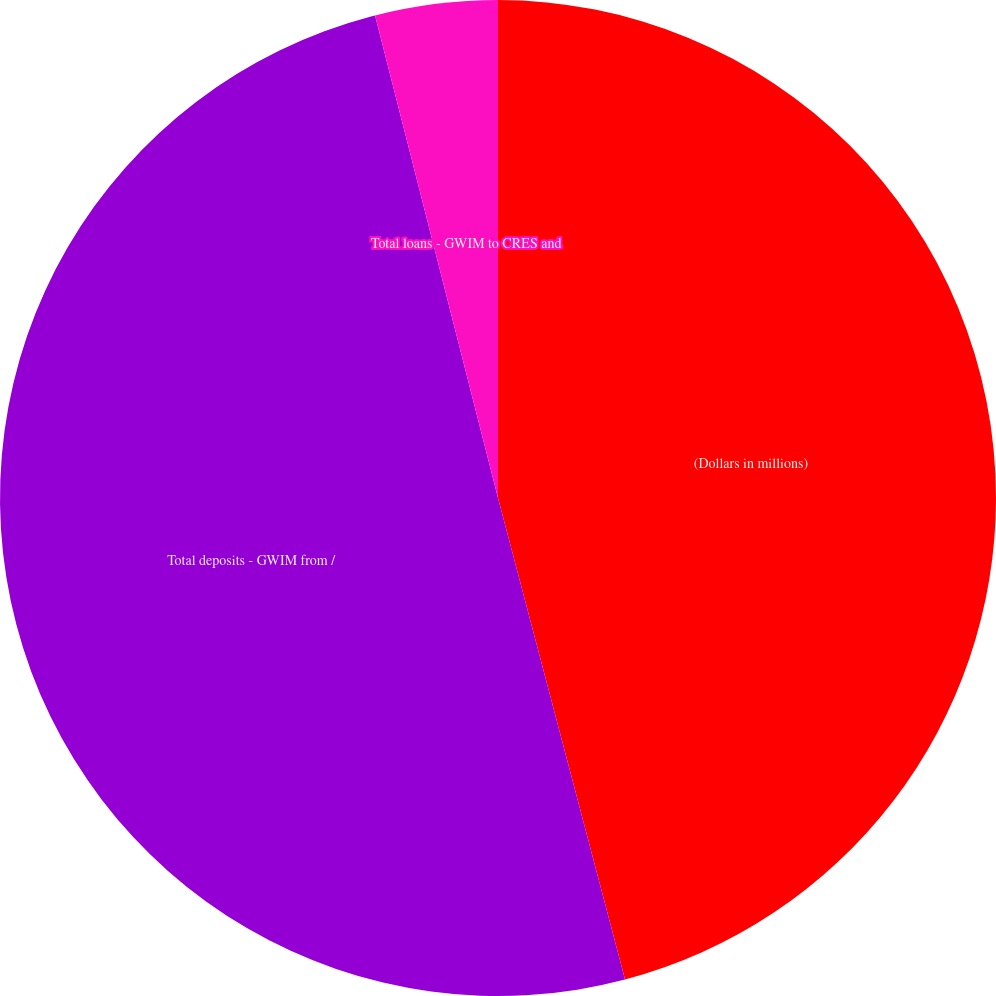Convert chart to OTSL. <chart><loc_0><loc_0><loc_500><loc_500><pie_chart><fcel>(Dollars in millions)<fcel>Total deposits - GWIM from /<fcel>Total loans - GWIM to CRES and<nl><fcel>45.89%<fcel>50.13%<fcel>3.97%<nl></chart> 